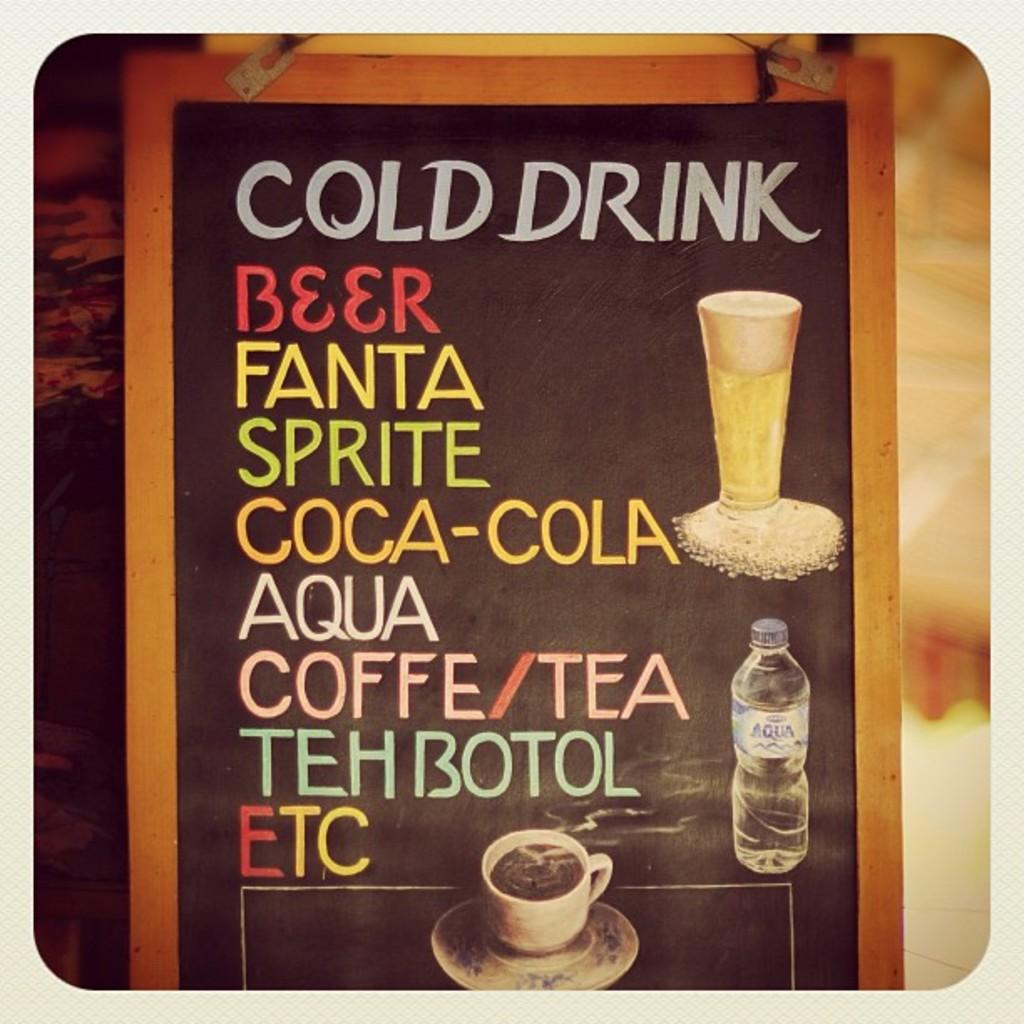<image>
Create a compact narrative representing the image presented. A cold drink menu offers a selection of sodas, coffee, and tea. 